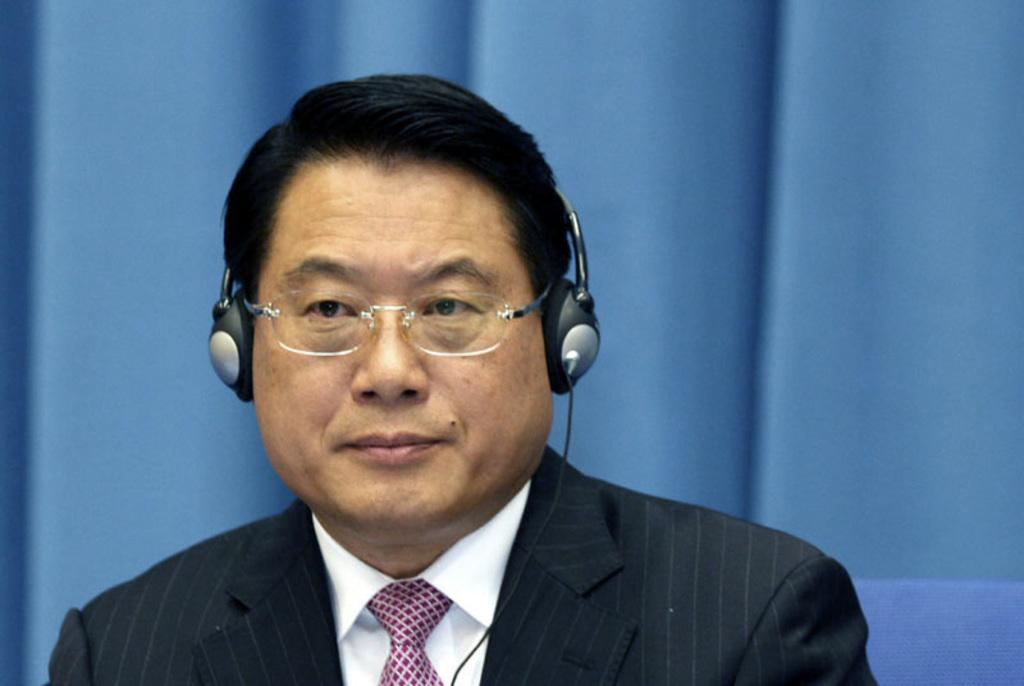What is the main subject of the image? The main subject of the image is a man. Can you describe the man's clothing in the image? The man is wearing a white shirt, a black coat, a tie, and spectacles. What is the man wearing on his head in the image? The man is wearing a headset in the image. What is the man's position in the image? The man is sitting on a chair in the image. What can be seen in the background of the image? There is a blue curtain in the background of the image. What is the man's side interest in the image? There is no information about the man's side interests in the image. What scene is depicted in the image? The image only shows a man sitting on a chair, wearing specific clothing and accessories, and there is a blue curtain in the background. There is no specific scene depicted. 